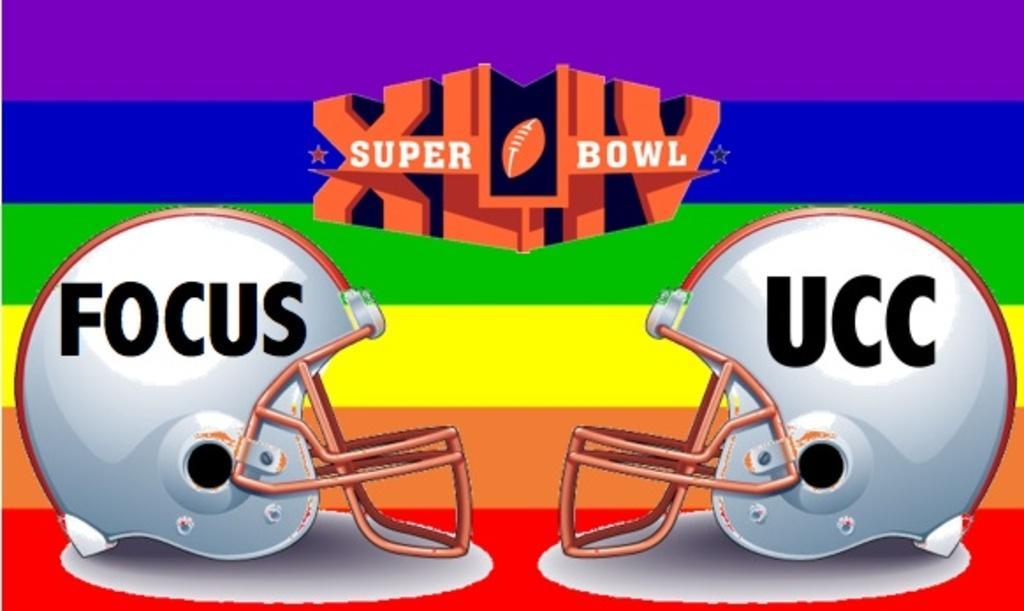Please provide a concise description of this image. In this picture I can see there are two helmets placed on the red color surface and there is something written on it. There is something written in the backdrop and there are different colors. 